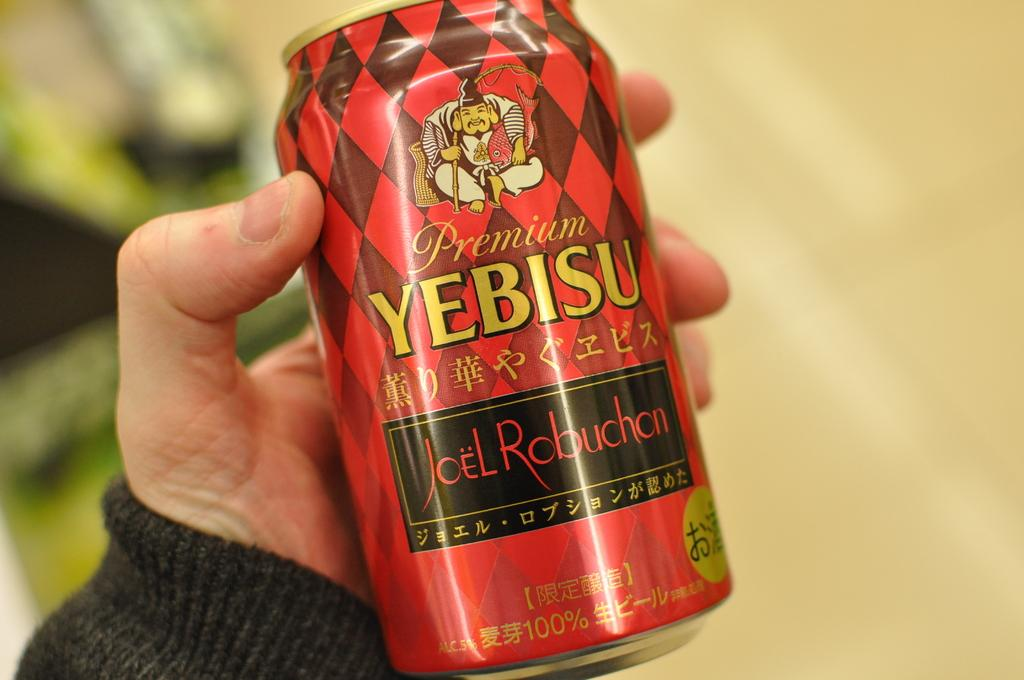Provide a one-sentence caption for the provided image. a Yebisu can in the person's hand in front of them. 